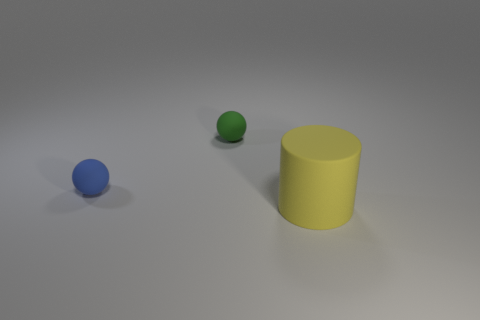There is a thing that is both to the left of the big thing and in front of the small green matte ball; how big is it?
Make the answer very short. Small. What color is the tiny object that is the same material as the green sphere?
Your answer should be compact. Blue. How many large cyan blocks are the same material as the small green object?
Provide a succinct answer. 0. Is the number of green objects that are behind the blue sphere the same as the number of cylinders behind the yellow rubber cylinder?
Your answer should be very brief. No. There is a small green rubber thing; does it have the same shape as the tiny thing that is in front of the green ball?
Make the answer very short. Yes. Is there anything else that is the same shape as the large rubber thing?
Your response must be concise. No. Is the material of the green sphere the same as the object right of the small green rubber object?
Provide a short and direct response. Yes. What color is the matte thing that is left of the object that is behind the matte sphere that is left of the green ball?
Ensure brevity in your answer.  Blue. Are there any other things that have the same size as the yellow cylinder?
Provide a short and direct response. No. What is the color of the rubber cylinder?
Give a very brief answer. Yellow. 